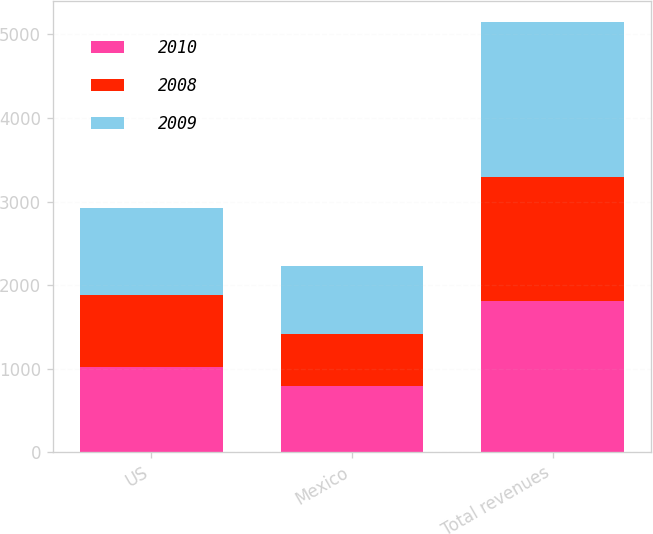<chart> <loc_0><loc_0><loc_500><loc_500><stacked_bar_chart><ecel><fcel>US<fcel>Mexico<fcel>Total revenues<nl><fcel>2010<fcel>1020.1<fcel>794.7<fcel>1814.8<nl><fcel>2008<fcel>864.2<fcel>616<fcel>1480.2<nl><fcel>2009<fcel>1033.6<fcel>818.5<fcel>1852.1<nl></chart> 